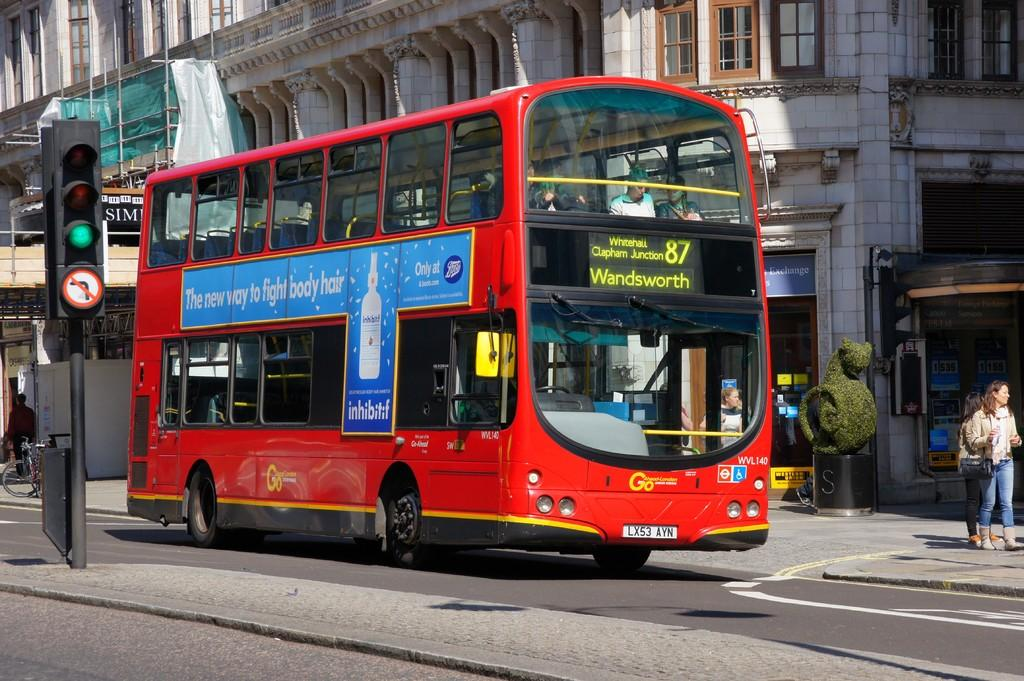<image>
Render a clear and concise summary of the photo. A red double decker bus has a bill board about fighting body hair. 